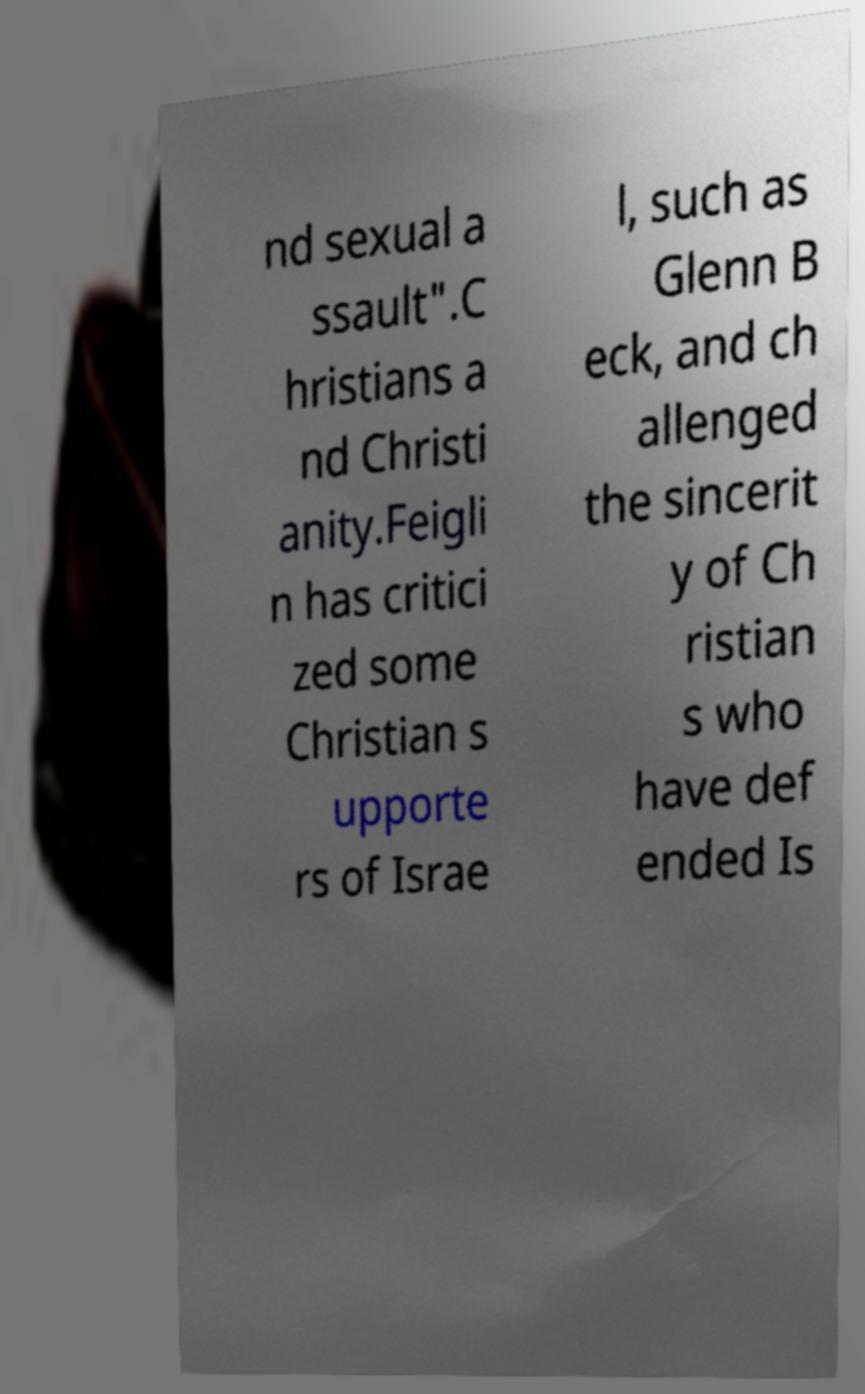There's text embedded in this image that I need extracted. Can you transcribe it verbatim? nd sexual a ssault".C hristians a nd Christi anity.Feigli n has critici zed some Christian s upporte rs of Israe l, such as Glenn B eck, and ch allenged the sincerit y of Ch ristian s who have def ended Is 